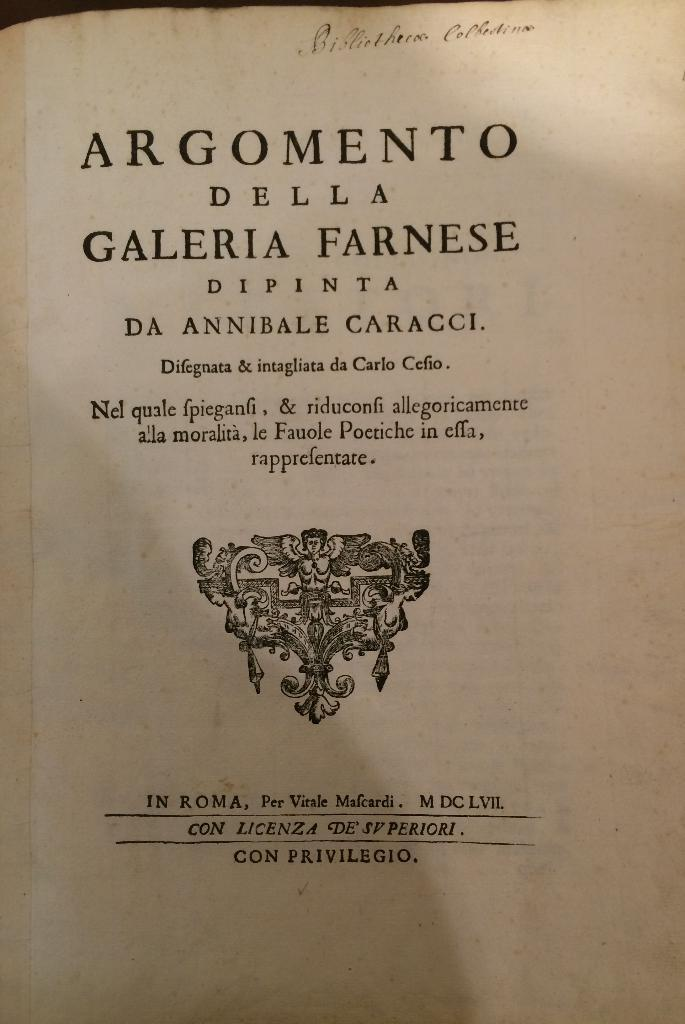Provide a one-sentence caption for the provided image. A book written in Italian sits open to its title page. 